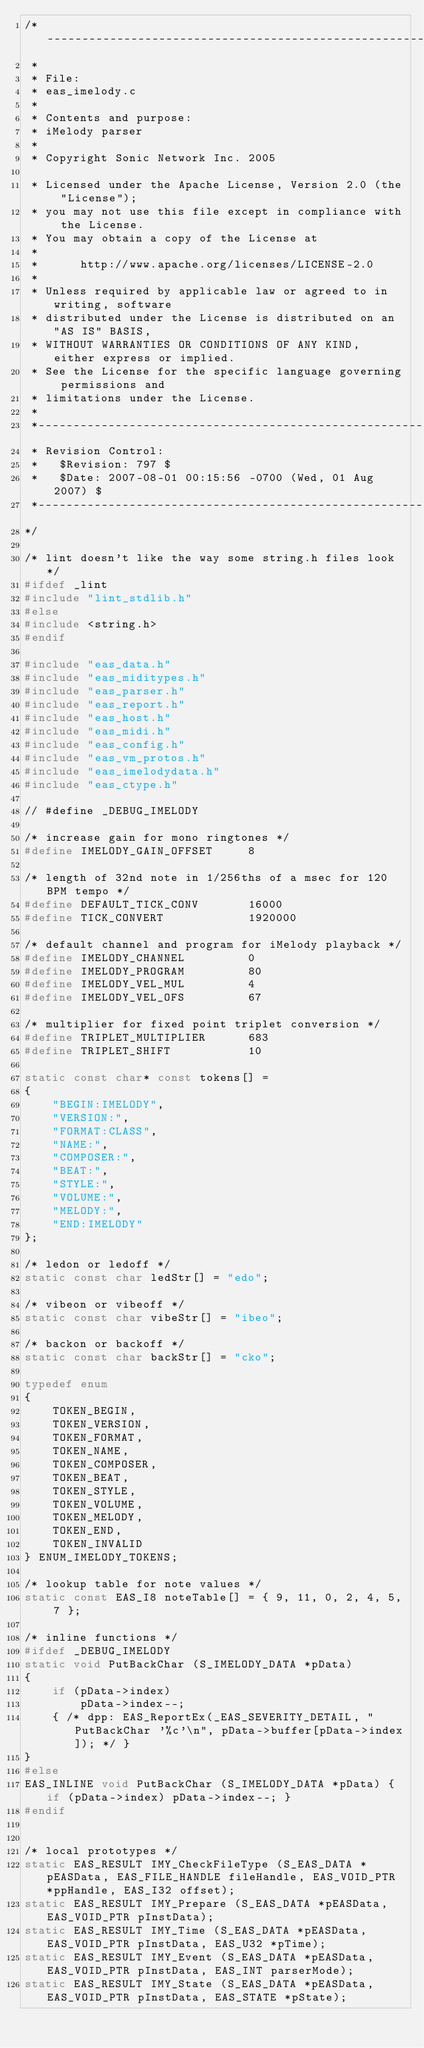Convert code to text. <code><loc_0><loc_0><loc_500><loc_500><_C_>/*----------------------------------------------------------------------------
 *
 * File:
 * eas_imelody.c
 *
 * Contents and purpose:
 * iMelody parser
 *
 * Copyright Sonic Network Inc. 2005

 * Licensed under the Apache License, Version 2.0 (the "License");
 * you may not use this file except in compliance with the License.
 * You may obtain a copy of the License at
 *
 *      http://www.apache.org/licenses/LICENSE-2.0
 *
 * Unless required by applicable law or agreed to in writing, software
 * distributed under the License is distributed on an "AS IS" BASIS,
 * WITHOUT WARRANTIES OR CONDITIONS OF ANY KIND, either express or implied.
 * See the License for the specific language governing permissions and
 * limitations under the License.
 *
 *----------------------------------------------------------------------------
 * Revision Control:
 *   $Revision: 797 $
 *   $Date: 2007-08-01 00:15:56 -0700 (Wed, 01 Aug 2007) $
 *----------------------------------------------------------------------------
*/

/* lint doesn't like the way some string.h files look */
#ifdef _lint
#include "lint_stdlib.h"
#else
#include <string.h>
#endif

#include "eas_data.h"
#include "eas_miditypes.h"
#include "eas_parser.h"
#include "eas_report.h"
#include "eas_host.h"
#include "eas_midi.h"
#include "eas_config.h"
#include "eas_vm_protos.h"
#include "eas_imelodydata.h"
#include "eas_ctype.h"

// #define _DEBUG_IMELODY

/* increase gain for mono ringtones */
#define IMELODY_GAIN_OFFSET     8

/* length of 32nd note in 1/256ths of a msec for 120 BPM tempo */
#define DEFAULT_TICK_CONV       16000
#define TICK_CONVERT            1920000

/* default channel and program for iMelody playback */
#define IMELODY_CHANNEL         0
#define IMELODY_PROGRAM         80
#define IMELODY_VEL_MUL         4
#define IMELODY_VEL_OFS         67

/* multiplier for fixed point triplet conversion */
#define TRIPLET_MULTIPLIER      683
#define TRIPLET_SHIFT           10

static const char* const tokens[] =
{
    "BEGIN:IMELODY",
    "VERSION:",
    "FORMAT:CLASS",
    "NAME:",
    "COMPOSER:",
    "BEAT:",
    "STYLE:",
    "VOLUME:",
    "MELODY:",
    "END:IMELODY"
};

/* ledon or ledoff */
static const char ledStr[] = "edo";

/* vibeon or vibeoff */
static const char vibeStr[] = "ibeo";

/* backon or backoff */
static const char backStr[] = "cko";

typedef enum
{
    TOKEN_BEGIN,
    TOKEN_VERSION,
    TOKEN_FORMAT,
    TOKEN_NAME,
    TOKEN_COMPOSER,
    TOKEN_BEAT,
    TOKEN_STYLE,
    TOKEN_VOLUME,
    TOKEN_MELODY,
    TOKEN_END,
    TOKEN_INVALID
} ENUM_IMELODY_TOKENS;

/* lookup table for note values */
static const EAS_I8 noteTable[] = { 9, 11, 0, 2, 4, 5, 7 };

/* inline functions */
#ifdef _DEBUG_IMELODY
static void PutBackChar (S_IMELODY_DATA *pData)
{
    if (pData->index)
        pData->index--;
    { /* dpp: EAS_ReportEx(_EAS_SEVERITY_DETAIL, "PutBackChar '%c'\n", pData->buffer[pData->index]); */ }
}
#else
EAS_INLINE void PutBackChar (S_IMELODY_DATA *pData) { if (pData->index) pData->index--; }
#endif


/* local prototypes */
static EAS_RESULT IMY_CheckFileType (S_EAS_DATA *pEASData, EAS_FILE_HANDLE fileHandle, EAS_VOID_PTR *ppHandle, EAS_I32 offset);
static EAS_RESULT IMY_Prepare (S_EAS_DATA *pEASData, EAS_VOID_PTR pInstData);
static EAS_RESULT IMY_Time (S_EAS_DATA *pEASData, EAS_VOID_PTR pInstData, EAS_U32 *pTime);
static EAS_RESULT IMY_Event (S_EAS_DATA *pEASData, EAS_VOID_PTR pInstData, EAS_INT parserMode);
static EAS_RESULT IMY_State (S_EAS_DATA *pEASData, EAS_VOID_PTR pInstData, EAS_STATE *pState);</code> 